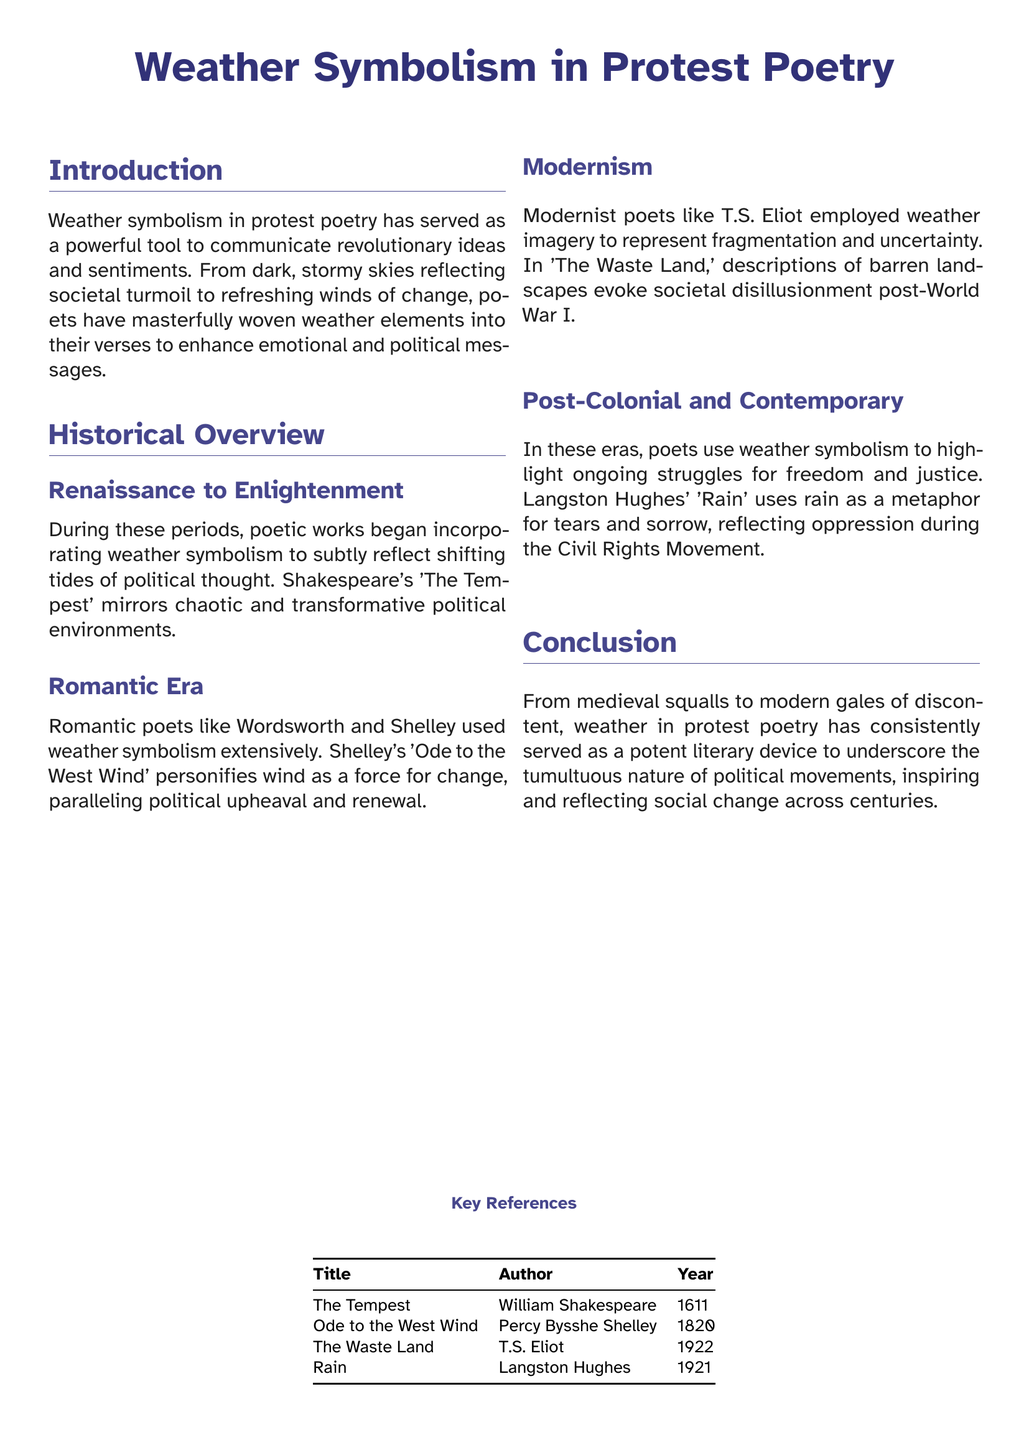What is the title of the document? The title of the document is presented prominently at the beginning, stating the focus of the content.
Answer: Weather Symbolism in Protest Poetry Who wrote 'Ode to the West Wind'? The document provides works and their authors in the references section, identifying the poet of the listed title.
Answer: Percy Bysshe Shelley What year was 'The Waste Land' published? The document includes a table of key references that lists publication years next to each work's title.
Answer: 1922 Which poet used rain as a metaphor during the Civil Rights Movement? The historical overview discusses various poets and their symbolism, specifically noting Langston Hughes' use of rain.
Answer: Langston Hughes What genre of poetry does 'The Tempest' belong to? The included content describes the historical context and works related to weather symbolism, implying the genre of the mentioned work.
Answer: Drama What does the wind symbolize in Shelley's poem? The analysis in the document identifies specific weather elements and their meanings, particularly in relation to political themes.
Answer: Change Which historical period does the document associate with increased use of weather symbolism? The introduction discusses how different historical periods have engaged with weather symbolism in protest poetry, indicating a relevant timeframe.
Answer: Renaissance to Enlightenment In which section is the historical overview located? The document is organized with section headings; the overview is explicitly labeled as a separate section.
Answer: Historical Overview 